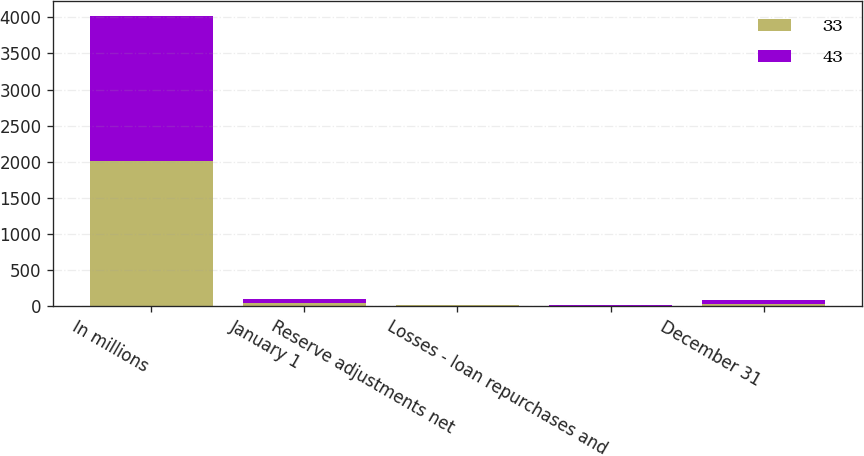Convert chart. <chart><loc_0><loc_0><loc_500><loc_500><stacked_bar_chart><ecel><fcel>In millions<fcel>January 1<fcel>Reserve adjustments net<fcel>Losses - loan repurchases and<fcel>December 31<nl><fcel>33<fcel>2013<fcel>43<fcel>9<fcel>1<fcel>33<nl><fcel>43<fcel>2012<fcel>47<fcel>4<fcel>8<fcel>43<nl></chart> 